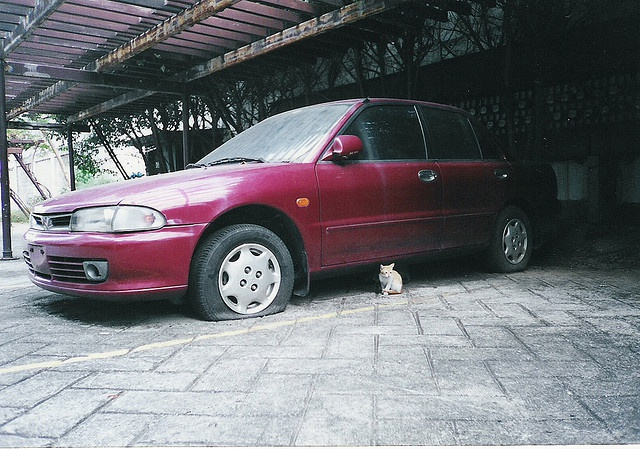Describe the objects in this image and their specific colors. I can see car in gray, black, maroon, lightgray, and brown tones and cat in gray, lightgray, and darkgray tones in this image. 